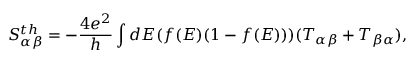Convert formula to latex. <formula><loc_0><loc_0><loc_500><loc_500>{ S _ { \alpha \beta } ^ { t h } } = - \frac { 4 e ^ { 2 } } { h } \int d E ( f ( E ) ( 1 - f ( E ) ) ) ( T _ { \alpha \beta } + T _ { \beta \alpha } ) ,</formula> 